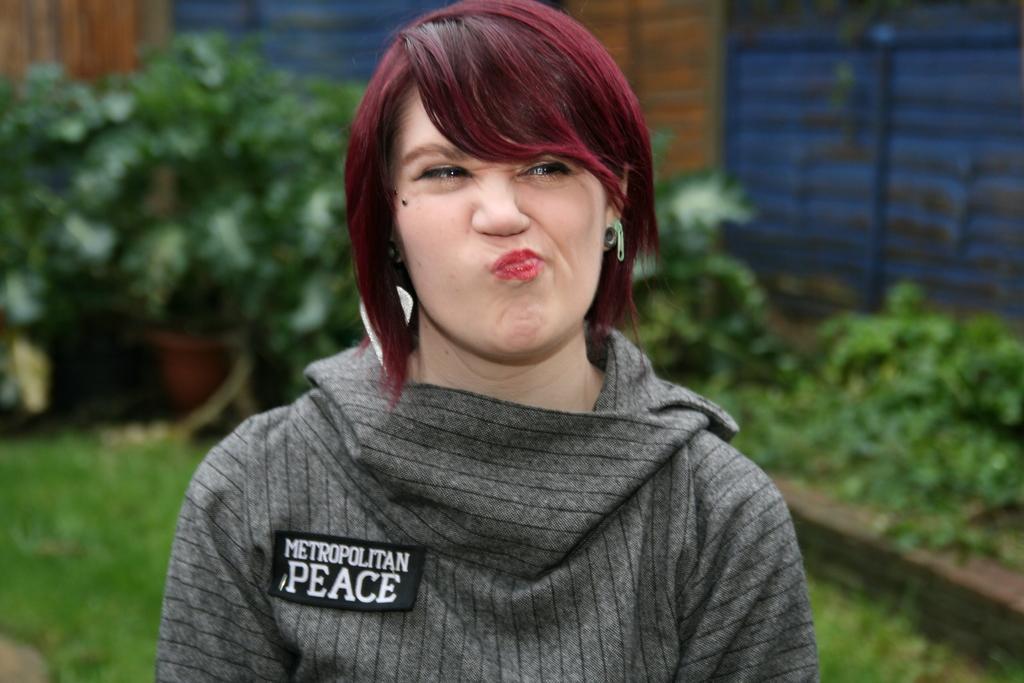In one or two sentences, can you explain what this image depicts? In this picture there is a person with grey t-shirt. At the back there is a building and there are trees. At the bottom there is grass. 